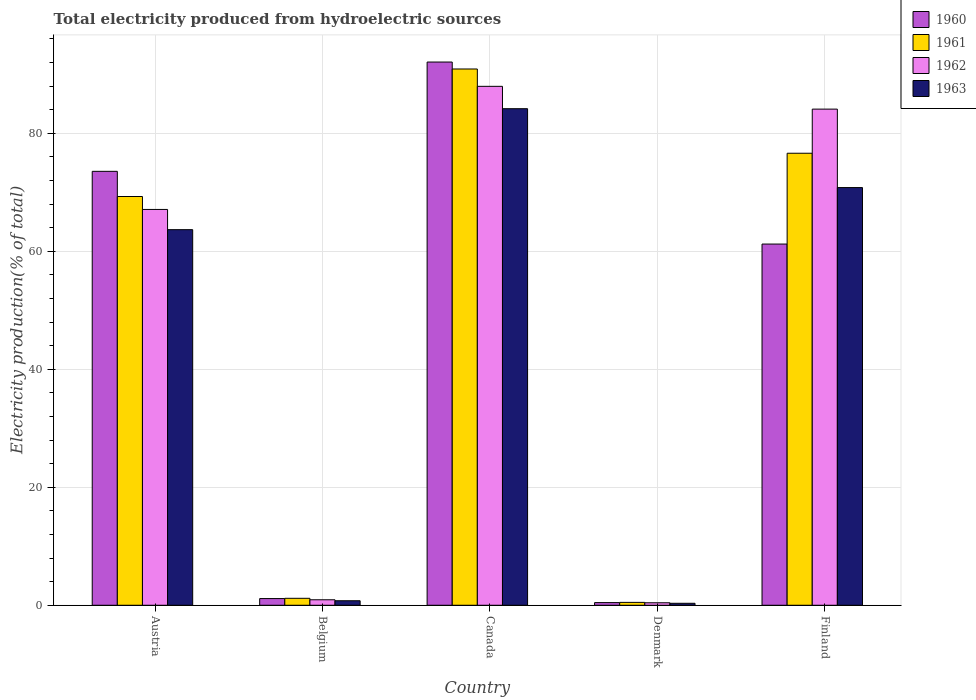How many different coloured bars are there?
Make the answer very short. 4. How many groups of bars are there?
Offer a terse response. 5. How many bars are there on the 1st tick from the left?
Your answer should be compact. 4. In how many cases, is the number of bars for a given country not equal to the number of legend labels?
Ensure brevity in your answer.  0. What is the total electricity produced in 1960 in Austria?
Provide a short and direct response. 73.56. Across all countries, what is the maximum total electricity produced in 1960?
Provide a short and direct response. 92.09. Across all countries, what is the minimum total electricity produced in 1963?
Offer a terse response. 0.33. In which country was the total electricity produced in 1962 maximum?
Ensure brevity in your answer.  Canada. In which country was the total electricity produced in 1963 minimum?
Give a very brief answer. Denmark. What is the total total electricity produced in 1960 in the graph?
Keep it short and to the point. 228.47. What is the difference between the total electricity produced in 1962 in Canada and that in Denmark?
Ensure brevity in your answer.  87.55. What is the difference between the total electricity produced in 1963 in Canada and the total electricity produced in 1960 in Finland?
Your answer should be very brief. 22.95. What is the average total electricity produced in 1960 per country?
Keep it short and to the point. 45.69. What is the difference between the total electricity produced of/in 1961 and total electricity produced of/in 1962 in Finland?
Ensure brevity in your answer.  -7.48. What is the ratio of the total electricity produced in 1962 in Denmark to that in Finland?
Provide a short and direct response. 0.01. Is the total electricity produced in 1962 in Belgium less than that in Canada?
Give a very brief answer. Yes. What is the difference between the highest and the second highest total electricity produced in 1962?
Make the answer very short. -17.01. What is the difference between the highest and the lowest total electricity produced in 1960?
Give a very brief answer. 91.64. Is it the case that in every country, the sum of the total electricity produced in 1963 and total electricity produced in 1960 is greater than the sum of total electricity produced in 1962 and total electricity produced in 1961?
Provide a succinct answer. No. What does the 1st bar from the left in Belgium represents?
Your response must be concise. 1960. What does the 4th bar from the right in Denmark represents?
Your answer should be very brief. 1960. How many bars are there?
Your answer should be very brief. 20. Are the values on the major ticks of Y-axis written in scientific E-notation?
Your answer should be very brief. No. How many legend labels are there?
Make the answer very short. 4. How are the legend labels stacked?
Make the answer very short. Vertical. What is the title of the graph?
Your answer should be very brief. Total electricity produced from hydroelectric sources. What is the label or title of the Y-axis?
Provide a short and direct response. Electricity production(% of total). What is the Electricity production(% of total) of 1960 in Austria?
Provide a short and direct response. 73.56. What is the Electricity production(% of total) in 1961 in Austria?
Keep it short and to the point. 69.29. What is the Electricity production(% of total) of 1962 in Austria?
Provide a short and direct response. 67.1. What is the Electricity production(% of total) in 1963 in Austria?
Keep it short and to the point. 63.67. What is the Electricity production(% of total) of 1960 in Belgium?
Your answer should be very brief. 1.14. What is the Electricity production(% of total) of 1961 in Belgium?
Ensure brevity in your answer.  1.18. What is the Electricity production(% of total) in 1962 in Belgium?
Give a very brief answer. 0.93. What is the Electricity production(% of total) of 1963 in Belgium?
Ensure brevity in your answer.  0.77. What is the Electricity production(% of total) in 1960 in Canada?
Provide a short and direct response. 92.09. What is the Electricity production(% of total) in 1961 in Canada?
Your response must be concise. 90.91. What is the Electricity production(% of total) of 1962 in Canada?
Your answer should be compact. 87.97. What is the Electricity production(% of total) in 1963 in Canada?
Keep it short and to the point. 84.18. What is the Electricity production(% of total) of 1960 in Denmark?
Offer a terse response. 0.45. What is the Electricity production(% of total) of 1961 in Denmark?
Your response must be concise. 0.49. What is the Electricity production(% of total) in 1962 in Denmark?
Your answer should be compact. 0.42. What is the Electricity production(% of total) of 1963 in Denmark?
Ensure brevity in your answer.  0.33. What is the Electricity production(% of total) of 1960 in Finland?
Provide a succinct answer. 61.23. What is the Electricity production(% of total) of 1961 in Finland?
Your answer should be compact. 76.63. What is the Electricity production(% of total) of 1962 in Finland?
Make the answer very short. 84.11. What is the Electricity production(% of total) of 1963 in Finland?
Your answer should be compact. 70.81. Across all countries, what is the maximum Electricity production(% of total) in 1960?
Provide a short and direct response. 92.09. Across all countries, what is the maximum Electricity production(% of total) in 1961?
Provide a short and direct response. 90.91. Across all countries, what is the maximum Electricity production(% of total) in 1962?
Keep it short and to the point. 87.97. Across all countries, what is the maximum Electricity production(% of total) in 1963?
Make the answer very short. 84.18. Across all countries, what is the minimum Electricity production(% of total) of 1960?
Your response must be concise. 0.45. Across all countries, what is the minimum Electricity production(% of total) of 1961?
Your answer should be compact. 0.49. Across all countries, what is the minimum Electricity production(% of total) in 1962?
Give a very brief answer. 0.42. Across all countries, what is the minimum Electricity production(% of total) of 1963?
Provide a succinct answer. 0.33. What is the total Electricity production(% of total) of 1960 in the graph?
Keep it short and to the point. 228.47. What is the total Electricity production(% of total) in 1961 in the graph?
Provide a short and direct response. 238.5. What is the total Electricity production(% of total) in 1962 in the graph?
Provide a succinct answer. 240.53. What is the total Electricity production(% of total) in 1963 in the graph?
Give a very brief answer. 219.76. What is the difference between the Electricity production(% of total) of 1960 in Austria and that in Belgium?
Keep it short and to the point. 72.42. What is the difference between the Electricity production(% of total) of 1961 in Austria and that in Belgium?
Your response must be concise. 68.11. What is the difference between the Electricity production(% of total) in 1962 in Austria and that in Belgium?
Provide a short and direct response. 66.17. What is the difference between the Electricity production(% of total) in 1963 in Austria and that in Belgium?
Your response must be concise. 62.91. What is the difference between the Electricity production(% of total) of 1960 in Austria and that in Canada?
Ensure brevity in your answer.  -18.53. What is the difference between the Electricity production(% of total) in 1961 in Austria and that in Canada?
Make the answer very short. -21.62. What is the difference between the Electricity production(% of total) of 1962 in Austria and that in Canada?
Give a very brief answer. -20.87. What is the difference between the Electricity production(% of total) of 1963 in Austria and that in Canada?
Your answer should be compact. -20.51. What is the difference between the Electricity production(% of total) of 1960 in Austria and that in Denmark?
Ensure brevity in your answer.  73.11. What is the difference between the Electricity production(% of total) of 1961 in Austria and that in Denmark?
Your response must be concise. 68.8. What is the difference between the Electricity production(% of total) in 1962 in Austria and that in Denmark?
Your response must be concise. 66.68. What is the difference between the Electricity production(% of total) in 1963 in Austria and that in Denmark?
Give a very brief answer. 63.34. What is the difference between the Electricity production(% of total) of 1960 in Austria and that in Finland?
Offer a very short reply. 12.33. What is the difference between the Electricity production(% of total) of 1961 in Austria and that in Finland?
Your response must be concise. -7.33. What is the difference between the Electricity production(% of total) of 1962 in Austria and that in Finland?
Provide a succinct answer. -17.01. What is the difference between the Electricity production(% of total) of 1963 in Austria and that in Finland?
Ensure brevity in your answer.  -7.14. What is the difference between the Electricity production(% of total) in 1960 in Belgium and that in Canada?
Ensure brevity in your answer.  -90.95. What is the difference between the Electricity production(% of total) in 1961 in Belgium and that in Canada?
Your response must be concise. -89.73. What is the difference between the Electricity production(% of total) of 1962 in Belgium and that in Canada?
Ensure brevity in your answer.  -87.04. What is the difference between the Electricity production(% of total) of 1963 in Belgium and that in Canada?
Make the answer very short. -83.41. What is the difference between the Electricity production(% of total) of 1960 in Belgium and that in Denmark?
Offer a terse response. 0.68. What is the difference between the Electricity production(% of total) of 1961 in Belgium and that in Denmark?
Your answer should be compact. 0.69. What is the difference between the Electricity production(% of total) in 1962 in Belgium and that in Denmark?
Offer a very short reply. 0.51. What is the difference between the Electricity production(% of total) in 1963 in Belgium and that in Denmark?
Provide a short and direct response. 0.43. What is the difference between the Electricity production(% of total) of 1960 in Belgium and that in Finland?
Give a very brief answer. -60.1. What is the difference between the Electricity production(% of total) in 1961 in Belgium and that in Finland?
Your response must be concise. -75.45. What is the difference between the Electricity production(% of total) of 1962 in Belgium and that in Finland?
Offer a very short reply. -83.18. What is the difference between the Electricity production(% of total) in 1963 in Belgium and that in Finland?
Offer a very short reply. -70.04. What is the difference between the Electricity production(% of total) in 1960 in Canada and that in Denmark?
Offer a very short reply. 91.64. What is the difference between the Electricity production(% of total) of 1961 in Canada and that in Denmark?
Offer a terse response. 90.42. What is the difference between the Electricity production(% of total) in 1962 in Canada and that in Denmark?
Give a very brief answer. 87.55. What is the difference between the Electricity production(% of total) in 1963 in Canada and that in Denmark?
Make the answer very short. 83.84. What is the difference between the Electricity production(% of total) in 1960 in Canada and that in Finland?
Give a very brief answer. 30.86. What is the difference between the Electricity production(% of total) of 1961 in Canada and that in Finland?
Offer a terse response. 14.28. What is the difference between the Electricity production(% of total) of 1962 in Canada and that in Finland?
Offer a very short reply. 3.86. What is the difference between the Electricity production(% of total) in 1963 in Canada and that in Finland?
Offer a very short reply. 13.37. What is the difference between the Electricity production(% of total) in 1960 in Denmark and that in Finland?
Offer a terse response. -60.78. What is the difference between the Electricity production(% of total) in 1961 in Denmark and that in Finland?
Your response must be concise. -76.14. What is the difference between the Electricity production(% of total) of 1962 in Denmark and that in Finland?
Ensure brevity in your answer.  -83.69. What is the difference between the Electricity production(% of total) of 1963 in Denmark and that in Finland?
Your answer should be very brief. -70.47. What is the difference between the Electricity production(% of total) in 1960 in Austria and the Electricity production(% of total) in 1961 in Belgium?
Provide a short and direct response. 72.38. What is the difference between the Electricity production(% of total) of 1960 in Austria and the Electricity production(% of total) of 1962 in Belgium?
Make the answer very short. 72.63. What is the difference between the Electricity production(% of total) in 1960 in Austria and the Electricity production(% of total) in 1963 in Belgium?
Make the answer very short. 72.79. What is the difference between the Electricity production(% of total) of 1961 in Austria and the Electricity production(% of total) of 1962 in Belgium?
Your answer should be compact. 68.36. What is the difference between the Electricity production(% of total) in 1961 in Austria and the Electricity production(% of total) in 1963 in Belgium?
Offer a terse response. 68.53. What is the difference between the Electricity production(% of total) in 1962 in Austria and the Electricity production(% of total) in 1963 in Belgium?
Provide a short and direct response. 66.33. What is the difference between the Electricity production(% of total) of 1960 in Austria and the Electricity production(% of total) of 1961 in Canada?
Your answer should be very brief. -17.35. What is the difference between the Electricity production(% of total) of 1960 in Austria and the Electricity production(% of total) of 1962 in Canada?
Offer a very short reply. -14.41. What is the difference between the Electricity production(% of total) in 1960 in Austria and the Electricity production(% of total) in 1963 in Canada?
Offer a very short reply. -10.62. What is the difference between the Electricity production(% of total) in 1961 in Austria and the Electricity production(% of total) in 1962 in Canada?
Keep it short and to the point. -18.67. What is the difference between the Electricity production(% of total) of 1961 in Austria and the Electricity production(% of total) of 1963 in Canada?
Ensure brevity in your answer.  -14.88. What is the difference between the Electricity production(% of total) in 1962 in Austria and the Electricity production(% of total) in 1963 in Canada?
Make the answer very short. -17.08. What is the difference between the Electricity production(% of total) of 1960 in Austria and the Electricity production(% of total) of 1961 in Denmark?
Your response must be concise. 73.07. What is the difference between the Electricity production(% of total) in 1960 in Austria and the Electricity production(% of total) in 1962 in Denmark?
Provide a short and direct response. 73.14. What is the difference between the Electricity production(% of total) in 1960 in Austria and the Electricity production(% of total) in 1963 in Denmark?
Offer a terse response. 73.22. What is the difference between the Electricity production(% of total) of 1961 in Austria and the Electricity production(% of total) of 1962 in Denmark?
Your answer should be very brief. 68.87. What is the difference between the Electricity production(% of total) of 1961 in Austria and the Electricity production(% of total) of 1963 in Denmark?
Keep it short and to the point. 68.96. What is the difference between the Electricity production(% of total) of 1962 in Austria and the Electricity production(% of total) of 1963 in Denmark?
Provide a succinct answer. 66.76. What is the difference between the Electricity production(% of total) in 1960 in Austria and the Electricity production(% of total) in 1961 in Finland?
Keep it short and to the point. -3.07. What is the difference between the Electricity production(% of total) in 1960 in Austria and the Electricity production(% of total) in 1962 in Finland?
Keep it short and to the point. -10.55. What is the difference between the Electricity production(% of total) in 1960 in Austria and the Electricity production(% of total) in 1963 in Finland?
Your answer should be very brief. 2.75. What is the difference between the Electricity production(% of total) of 1961 in Austria and the Electricity production(% of total) of 1962 in Finland?
Provide a succinct answer. -14.81. What is the difference between the Electricity production(% of total) in 1961 in Austria and the Electricity production(% of total) in 1963 in Finland?
Your response must be concise. -1.51. What is the difference between the Electricity production(% of total) of 1962 in Austria and the Electricity production(% of total) of 1963 in Finland?
Offer a very short reply. -3.71. What is the difference between the Electricity production(% of total) of 1960 in Belgium and the Electricity production(% of total) of 1961 in Canada?
Provide a short and direct response. -89.78. What is the difference between the Electricity production(% of total) of 1960 in Belgium and the Electricity production(% of total) of 1962 in Canada?
Keep it short and to the point. -86.83. What is the difference between the Electricity production(% of total) in 1960 in Belgium and the Electricity production(% of total) in 1963 in Canada?
Provide a succinct answer. -83.04. What is the difference between the Electricity production(% of total) of 1961 in Belgium and the Electricity production(% of total) of 1962 in Canada?
Offer a very short reply. -86.79. What is the difference between the Electricity production(% of total) in 1961 in Belgium and the Electricity production(% of total) in 1963 in Canada?
Provide a succinct answer. -83. What is the difference between the Electricity production(% of total) of 1962 in Belgium and the Electricity production(% of total) of 1963 in Canada?
Your response must be concise. -83.25. What is the difference between the Electricity production(% of total) in 1960 in Belgium and the Electricity production(% of total) in 1961 in Denmark?
Your answer should be compact. 0.65. What is the difference between the Electricity production(% of total) in 1960 in Belgium and the Electricity production(% of total) in 1962 in Denmark?
Your answer should be very brief. 0.71. What is the difference between the Electricity production(% of total) in 1960 in Belgium and the Electricity production(% of total) in 1963 in Denmark?
Offer a terse response. 0.8. What is the difference between the Electricity production(% of total) of 1961 in Belgium and the Electricity production(% of total) of 1962 in Denmark?
Ensure brevity in your answer.  0.76. What is the difference between the Electricity production(% of total) of 1961 in Belgium and the Electricity production(% of total) of 1963 in Denmark?
Keep it short and to the point. 0.84. What is the difference between the Electricity production(% of total) of 1962 in Belgium and the Electricity production(% of total) of 1963 in Denmark?
Offer a very short reply. 0.59. What is the difference between the Electricity production(% of total) in 1960 in Belgium and the Electricity production(% of total) in 1961 in Finland?
Your answer should be compact. -75.49. What is the difference between the Electricity production(% of total) of 1960 in Belgium and the Electricity production(% of total) of 1962 in Finland?
Offer a very short reply. -82.97. What is the difference between the Electricity production(% of total) of 1960 in Belgium and the Electricity production(% of total) of 1963 in Finland?
Keep it short and to the point. -69.67. What is the difference between the Electricity production(% of total) in 1961 in Belgium and the Electricity production(% of total) in 1962 in Finland?
Keep it short and to the point. -82.93. What is the difference between the Electricity production(% of total) in 1961 in Belgium and the Electricity production(% of total) in 1963 in Finland?
Keep it short and to the point. -69.63. What is the difference between the Electricity production(% of total) of 1962 in Belgium and the Electricity production(% of total) of 1963 in Finland?
Your response must be concise. -69.88. What is the difference between the Electricity production(% of total) in 1960 in Canada and the Electricity production(% of total) in 1961 in Denmark?
Ensure brevity in your answer.  91.6. What is the difference between the Electricity production(% of total) in 1960 in Canada and the Electricity production(% of total) in 1962 in Denmark?
Keep it short and to the point. 91.67. What is the difference between the Electricity production(% of total) of 1960 in Canada and the Electricity production(% of total) of 1963 in Denmark?
Your answer should be compact. 91.75. What is the difference between the Electricity production(% of total) in 1961 in Canada and the Electricity production(% of total) in 1962 in Denmark?
Give a very brief answer. 90.49. What is the difference between the Electricity production(% of total) of 1961 in Canada and the Electricity production(% of total) of 1963 in Denmark?
Provide a succinct answer. 90.58. What is the difference between the Electricity production(% of total) of 1962 in Canada and the Electricity production(% of total) of 1963 in Denmark?
Provide a succinct answer. 87.63. What is the difference between the Electricity production(% of total) of 1960 in Canada and the Electricity production(% of total) of 1961 in Finland?
Your answer should be very brief. 15.46. What is the difference between the Electricity production(% of total) in 1960 in Canada and the Electricity production(% of total) in 1962 in Finland?
Ensure brevity in your answer.  7.98. What is the difference between the Electricity production(% of total) of 1960 in Canada and the Electricity production(% of total) of 1963 in Finland?
Keep it short and to the point. 21.28. What is the difference between the Electricity production(% of total) of 1961 in Canada and the Electricity production(% of total) of 1962 in Finland?
Offer a very short reply. 6.8. What is the difference between the Electricity production(% of total) in 1961 in Canada and the Electricity production(% of total) in 1963 in Finland?
Keep it short and to the point. 20.1. What is the difference between the Electricity production(% of total) in 1962 in Canada and the Electricity production(% of total) in 1963 in Finland?
Your answer should be very brief. 17.16. What is the difference between the Electricity production(% of total) of 1960 in Denmark and the Electricity production(% of total) of 1961 in Finland?
Ensure brevity in your answer.  -76.18. What is the difference between the Electricity production(% of total) of 1960 in Denmark and the Electricity production(% of total) of 1962 in Finland?
Provide a succinct answer. -83.66. What is the difference between the Electricity production(% of total) in 1960 in Denmark and the Electricity production(% of total) in 1963 in Finland?
Offer a very short reply. -70.36. What is the difference between the Electricity production(% of total) in 1961 in Denmark and the Electricity production(% of total) in 1962 in Finland?
Offer a terse response. -83.62. What is the difference between the Electricity production(% of total) in 1961 in Denmark and the Electricity production(% of total) in 1963 in Finland?
Keep it short and to the point. -70.32. What is the difference between the Electricity production(% of total) in 1962 in Denmark and the Electricity production(% of total) in 1963 in Finland?
Give a very brief answer. -70.39. What is the average Electricity production(% of total) of 1960 per country?
Make the answer very short. 45.69. What is the average Electricity production(% of total) in 1961 per country?
Provide a short and direct response. 47.7. What is the average Electricity production(% of total) in 1962 per country?
Offer a terse response. 48.11. What is the average Electricity production(% of total) in 1963 per country?
Your answer should be compact. 43.95. What is the difference between the Electricity production(% of total) of 1960 and Electricity production(% of total) of 1961 in Austria?
Your response must be concise. 4.27. What is the difference between the Electricity production(% of total) in 1960 and Electricity production(% of total) in 1962 in Austria?
Offer a terse response. 6.46. What is the difference between the Electricity production(% of total) in 1960 and Electricity production(% of total) in 1963 in Austria?
Your answer should be compact. 9.89. What is the difference between the Electricity production(% of total) in 1961 and Electricity production(% of total) in 1962 in Austria?
Keep it short and to the point. 2.19. What is the difference between the Electricity production(% of total) of 1961 and Electricity production(% of total) of 1963 in Austria?
Your answer should be very brief. 5.62. What is the difference between the Electricity production(% of total) of 1962 and Electricity production(% of total) of 1963 in Austria?
Provide a succinct answer. 3.43. What is the difference between the Electricity production(% of total) in 1960 and Electricity production(% of total) in 1961 in Belgium?
Offer a terse response. -0.04. What is the difference between the Electricity production(% of total) in 1960 and Electricity production(% of total) in 1962 in Belgium?
Your response must be concise. 0.21. What is the difference between the Electricity production(% of total) in 1960 and Electricity production(% of total) in 1963 in Belgium?
Give a very brief answer. 0.37. What is the difference between the Electricity production(% of total) of 1961 and Electricity production(% of total) of 1962 in Belgium?
Provide a succinct answer. 0.25. What is the difference between the Electricity production(% of total) of 1961 and Electricity production(% of total) of 1963 in Belgium?
Your answer should be compact. 0.41. What is the difference between the Electricity production(% of total) of 1962 and Electricity production(% of total) of 1963 in Belgium?
Provide a succinct answer. 0.16. What is the difference between the Electricity production(% of total) of 1960 and Electricity production(% of total) of 1961 in Canada?
Ensure brevity in your answer.  1.18. What is the difference between the Electricity production(% of total) of 1960 and Electricity production(% of total) of 1962 in Canada?
Keep it short and to the point. 4.12. What is the difference between the Electricity production(% of total) of 1960 and Electricity production(% of total) of 1963 in Canada?
Your answer should be very brief. 7.91. What is the difference between the Electricity production(% of total) in 1961 and Electricity production(% of total) in 1962 in Canada?
Offer a very short reply. 2.94. What is the difference between the Electricity production(% of total) of 1961 and Electricity production(% of total) of 1963 in Canada?
Provide a succinct answer. 6.73. What is the difference between the Electricity production(% of total) of 1962 and Electricity production(% of total) of 1963 in Canada?
Make the answer very short. 3.79. What is the difference between the Electricity production(% of total) in 1960 and Electricity production(% of total) in 1961 in Denmark?
Offer a very short reply. -0.04. What is the difference between the Electricity production(% of total) in 1960 and Electricity production(% of total) in 1962 in Denmark?
Offer a very short reply. 0.03. What is the difference between the Electricity production(% of total) of 1960 and Electricity production(% of total) of 1963 in Denmark?
Provide a short and direct response. 0.12. What is the difference between the Electricity production(% of total) in 1961 and Electricity production(% of total) in 1962 in Denmark?
Give a very brief answer. 0.07. What is the difference between the Electricity production(% of total) in 1961 and Electricity production(% of total) in 1963 in Denmark?
Your response must be concise. 0.15. What is the difference between the Electricity production(% of total) in 1962 and Electricity production(% of total) in 1963 in Denmark?
Offer a terse response. 0.09. What is the difference between the Electricity production(% of total) of 1960 and Electricity production(% of total) of 1961 in Finland?
Your response must be concise. -15.4. What is the difference between the Electricity production(% of total) of 1960 and Electricity production(% of total) of 1962 in Finland?
Offer a very short reply. -22.88. What is the difference between the Electricity production(% of total) in 1960 and Electricity production(% of total) in 1963 in Finland?
Provide a succinct answer. -9.58. What is the difference between the Electricity production(% of total) of 1961 and Electricity production(% of total) of 1962 in Finland?
Your answer should be very brief. -7.48. What is the difference between the Electricity production(% of total) in 1961 and Electricity production(% of total) in 1963 in Finland?
Give a very brief answer. 5.82. What is the difference between the Electricity production(% of total) in 1962 and Electricity production(% of total) in 1963 in Finland?
Your answer should be very brief. 13.3. What is the ratio of the Electricity production(% of total) in 1960 in Austria to that in Belgium?
Your answer should be very brief. 64.8. What is the ratio of the Electricity production(% of total) in 1961 in Austria to that in Belgium?
Offer a very short reply. 58.77. What is the ratio of the Electricity production(% of total) in 1962 in Austria to that in Belgium?
Your answer should be compact. 72.22. What is the ratio of the Electricity production(% of total) of 1963 in Austria to that in Belgium?
Offer a terse response. 83.18. What is the ratio of the Electricity production(% of total) in 1960 in Austria to that in Canada?
Ensure brevity in your answer.  0.8. What is the ratio of the Electricity production(% of total) of 1961 in Austria to that in Canada?
Offer a terse response. 0.76. What is the ratio of the Electricity production(% of total) in 1962 in Austria to that in Canada?
Provide a succinct answer. 0.76. What is the ratio of the Electricity production(% of total) in 1963 in Austria to that in Canada?
Offer a terse response. 0.76. What is the ratio of the Electricity production(% of total) in 1960 in Austria to that in Denmark?
Make the answer very short. 163.01. What is the ratio of the Electricity production(% of total) of 1961 in Austria to that in Denmark?
Provide a succinct answer. 141.68. What is the ratio of the Electricity production(% of total) of 1962 in Austria to that in Denmark?
Provide a short and direct response. 159.41. What is the ratio of the Electricity production(% of total) of 1963 in Austria to that in Denmark?
Make the answer very short. 190.38. What is the ratio of the Electricity production(% of total) of 1960 in Austria to that in Finland?
Your answer should be compact. 1.2. What is the ratio of the Electricity production(% of total) of 1961 in Austria to that in Finland?
Your answer should be very brief. 0.9. What is the ratio of the Electricity production(% of total) of 1962 in Austria to that in Finland?
Give a very brief answer. 0.8. What is the ratio of the Electricity production(% of total) of 1963 in Austria to that in Finland?
Keep it short and to the point. 0.9. What is the ratio of the Electricity production(% of total) in 1960 in Belgium to that in Canada?
Your answer should be very brief. 0.01. What is the ratio of the Electricity production(% of total) in 1961 in Belgium to that in Canada?
Your answer should be very brief. 0.01. What is the ratio of the Electricity production(% of total) of 1962 in Belgium to that in Canada?
Offer a very short reply. 0.01. What is the ratio of the Electricity production(% of total) of 1963 in Belgium to that in Canada?
Your answer should be very brief. 0.01. What is the ratio of the Electricity production(% of total) of 1960 in Belgium to that in Denmark?
Keep it short and to the point. 2.52. What is the ratio of the Electricity production(% of total) in 1961 in Belgium to that in Denmark?
Keep it short and to the point. 2.41. What is the ratio of the Electricity production(% of total) of 1962 in Belgium to that in Denmark?
Ensure brevity in your answer.  2.21. What is the ratio of the Electricity production(% of total) of 1963 in Belgium to that in Denmark?
Your answer should be very brief. 2.29. What is the ratio of the Electricity production(% of total) of 1960 in Belgium to that in Finland?
Your answer should be compact. 0.02. What is the ratio of the Electricity production(% of total) of 1961 in Belgium to that in Finland?
Your response must be concise. 0.02. What is the ratio of the Electricity production(% of total) in 1962 in Belgium to that in Finland?
Provide a short and direct response. 0.01. What is the ratio of the Electricity production(% of total) of 1963 in Belgium to that in Finland?
Your answer should be very brief. 0.01. What is the ratio of the Electricity production(% of total) in 1960 in Canada to that in Denmark?
Offer a very short reply. 204.07. What is the ratio of the Electricity production(% of total) of 1961 in Canada to that in Denmark?
Give a very brief answer. 185.88. What is the ratio of the Electricity production(% of total) of 1962 in Canada to that in Denmark?
Make the answer very short. 208.99. What is the ratio of the Electricity production(% of total) in 1963 in Canada to that in Denmark?
Offer a very short reply. 251.69. What is the ratio of the Electricity production(% of total) in 1960 in Canada to that in Finland?
Offer a very short reply. 1.5. What is the ratio of the Electricity production(% of total) in 1961 in Canada to that in Finland?
Your answer should be compact. 1.19. What is the ratio of the Electricity production(% of total) of 1962 in Canada to that in Finland?
Your answer should be very brief. 1.05. What is the ratio of the Electricity production(% of total) in 1963 in Canada to that in Finland?
Ensure brevity in your answer.  1.19. What is the ratio of the Electricity production(% of total) in 1960 in Denmark to that in Finland?
Your answer should be very brief. 0.01. What is the ratio of the Electricity production(% of total) of 1961 in Denmark to that in Finland?
Ensure brevity in your answer.  0.01. What is the ratio of the Electricity production(% of total) of 1962 in Denmark to that in Finland?
Keep it short and to the point. 0.01. What is the ratio of the Electricity production(% of total) in 1963 in Denmark to that in Finland?
Your answer should be very brief. 0. What is the difference between the highest and the second highest Electricity production(% of total) in 1960?
Offer a very short reply. 18.53. What is the difference between the highest and the second highest Electricity production(% of total) of 1961?
Keep it short and to the point. 14.28. What is the difference between the highest and the second highest Electricity production(% of total) in 1962?
Your answer should be very brief. 3.86. What is the difference between the highest and the second highest Electricity production(% of total) in 1963?
Your answer should be compact. 13.37. What is the difference between the highest and the lowest Electricity production(% of total) of 1960?
Keep it short and to the point. 91.64. What is the difference between the highest and the lowest Electricity production(% of total) of 1961?
Your response must be concise. 90.42. What is the difference between the highest and the lowest Electricity production(% of total) of 1962?
Offer a terse response. 87.55. What is the difference between the highest and the lowest Electricity production(% of total) in 1963?
Your answer should be compact. 83.84. 